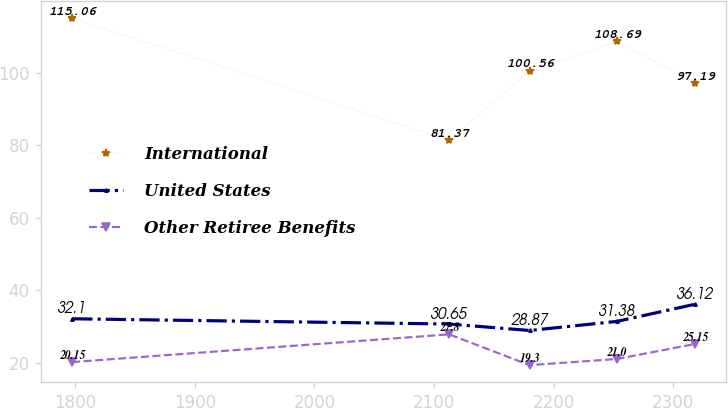Convert chart. <chart><loc_0><loc_0><loc_500><loc_500><line_chart><ecel><fcel>International<fcel>United States<fcel>Other Retiree Benefits<nl><fcel>1797.57<fcel>115.06<fcel>32.1<fcel>20.15<nl><fcel>2112.74<fcel>81.37<fcel>30.65<fcel>27.8<nl><fcel>2180.04<fcel>100.56<fcel>28.87<fcel>19.3<nl><fcel>2253.06<fcel>108.69<fcel>31.38<fcel>21<nl><fcel>2318.38<fcel>97.19<fcel>36.12<fcel>25.15<nl></chart> 